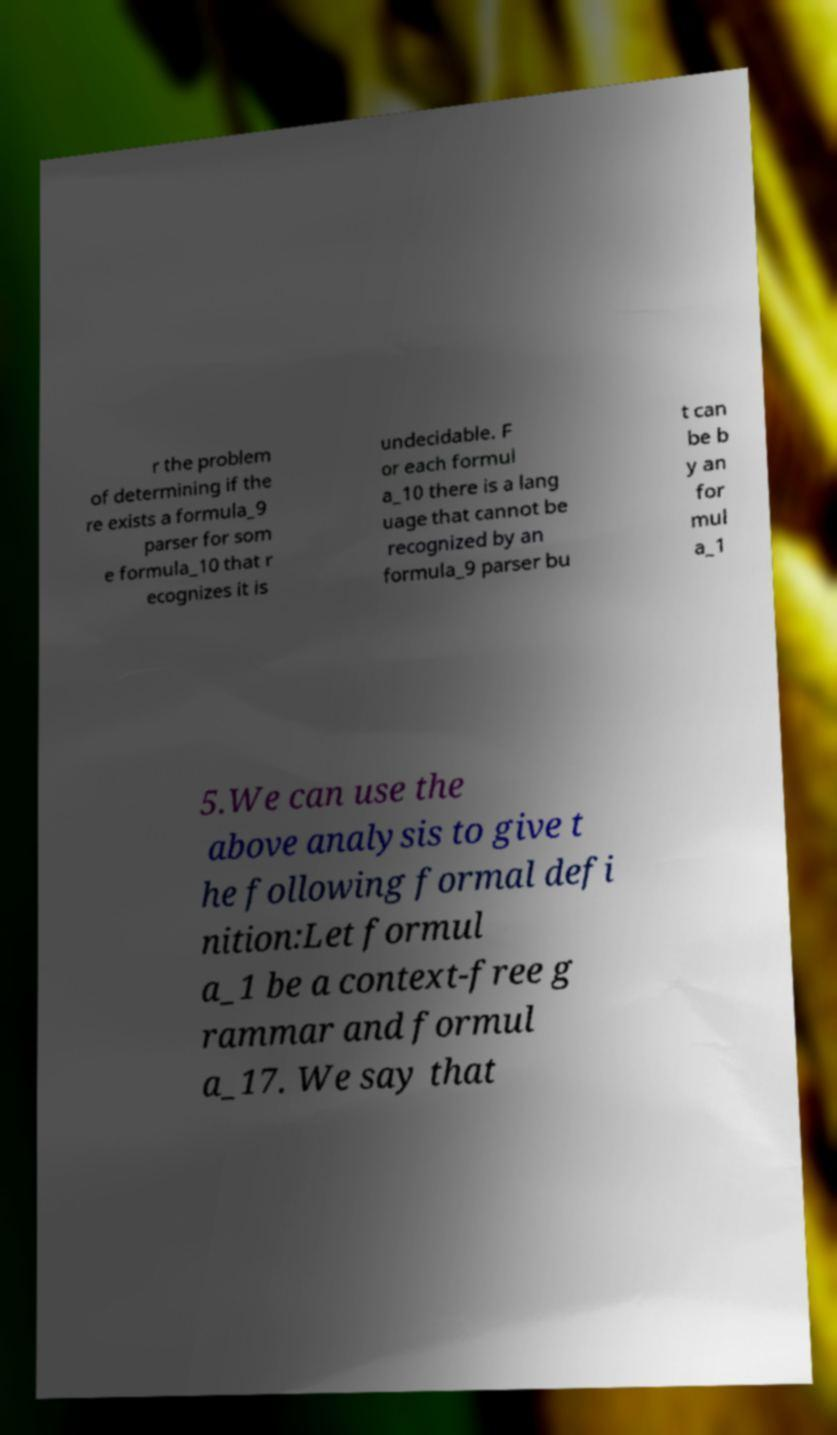Could you assist in decoding the text presented in this image and type it out clearly? r the problem of determining if the re exists a formula_9 parser for som e formula_10 that r ecognizes it is undecidable. F or each formul a_10 there is a lang uage that cannot be recognized by an formula_9 parser bu t can be b y an for mul a_1 5.We can use the above analysis to give t he following formal defi nition:Let formul a_1 be a context-free g rammar and formul a_17. We say that 